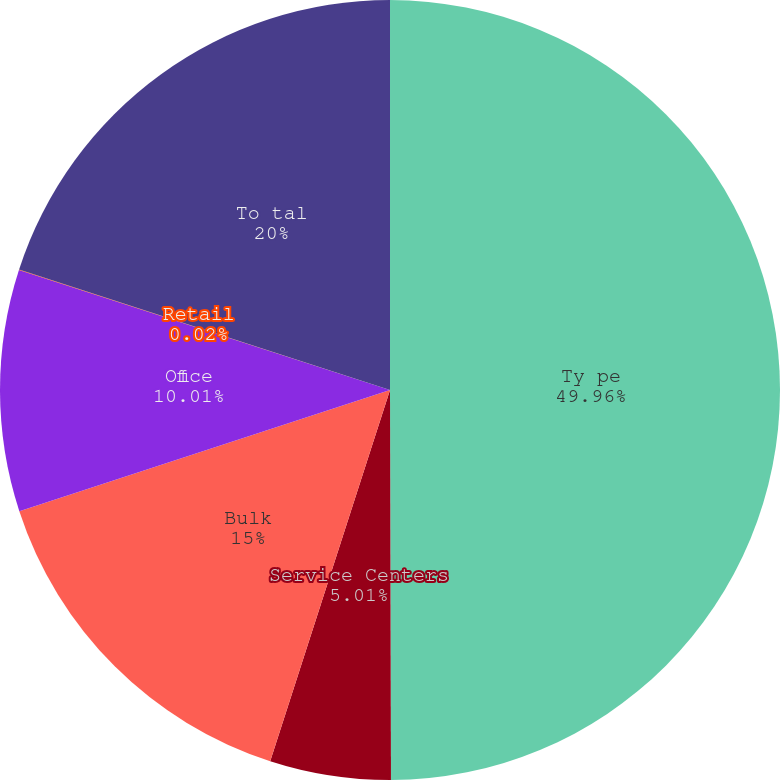<chart> <loc_0><loc_0><loc_500><loc_500><pie_chart><fcel>Ty pe<fcel>Service Centers<fcel>Bulk<fcel>Office<fcel>Retail<fcel>To tal<nl><fcel>49.96%<fcel>5.01%<fcel>15.0%<fcel>10.01%<fcel>0.02%<fcel>20.0%<nl></chart> 